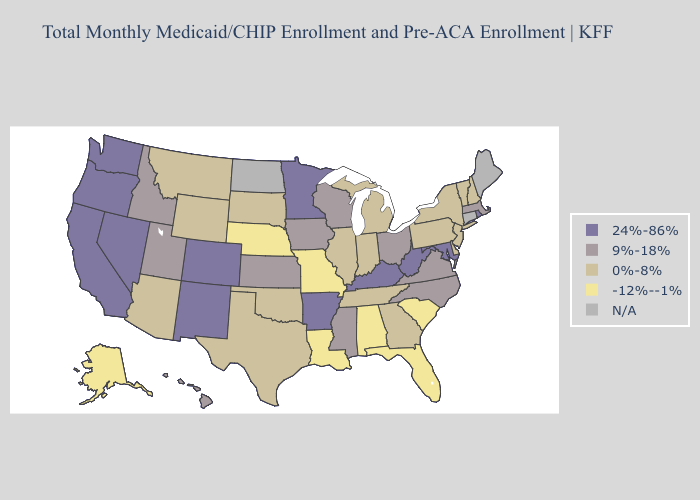Name the states that have a value in the range N/A?
Give a very brief answer. Connecticut, Maine, North Dakota. Name the states that have a value in the range 24%-86%?
Concise answer only. Arkansas, California, Colorado, Kentucky, Maryland, Minnesota, Nevada, New Mexico, Oregon, Rhode Island, Washington, West Virginia. What is the lowest value in the Northeast?
Quick response, please. 0%-8%. Among the states that border Arkansas , does Oklahoma have the lowest value?
Give a very brief answer. No. Among the states that border Washington , does Idaho have the lowest value?
Write a very short answer. Yes. What is the highest value in the USA?
Short answer required. 24%-86%. Name the states that have a value in the range 0%-8%?
Answer briefly. Arizona, Delaware, Georgia, Illinois, Indiana, Michigan, Montana, New Hampshire, New Jersey, New York, Oklahoma, Pennsylvania, South Dakota, Tennessee, Texas, Vermont, Wyoming. What is the value of Montana?
Concise answer only. 0%-8%. Name the states that have a value in the range 9%-18%?
Quick response, please. Hawaii, Idaho, Iowa, Kansas, Massachusetts, Mississippi, North Carolina, Ohio, Utah, Virginia, Wisconsin. Does Minnesota have the highest value in the MidWest?
Keep it brief. Yes. What is the highest value in the Northeast ?
Be succinct. 24%-86%. What is the highest value in states that border Arizona?
Give a very brief answer. 24%-86%. What is the value of Georgia?
Give a very brief answer. 0%-8%. Name the states that have a value in the range 9%-18%?
Give a very brief answer. Hawaii, Idaho, Iowa, Kansas, Massachusetts, Mississippi, North Carolina, Ohio, Utah, Virginia, Wisconsin. 